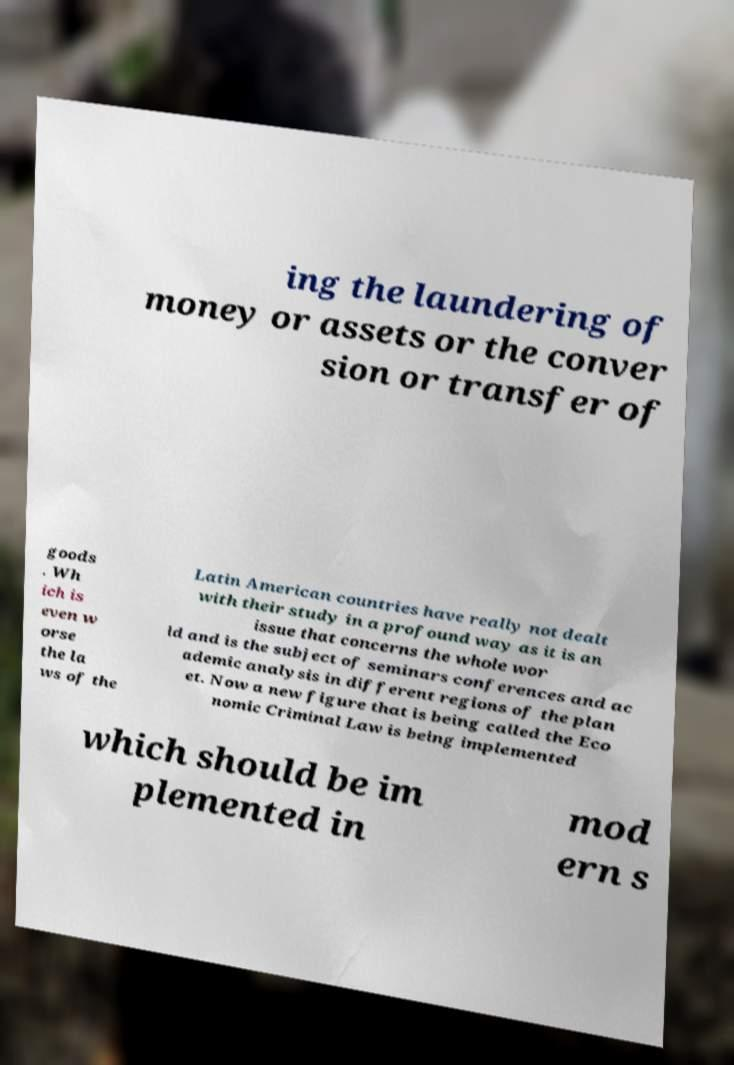Can you accurately transcribe the text from the provided image for me? ing the laundering of money or assets or the conver sion or transfer of goods . Wh ich is even w orse the la ws of the Latin American countries have really not dealt with their study in a profound way as it is an issue that concerns the whole wor ld and is the subject of seminars conferences and ac ademic analysis in different regions of the plan et. Now a new figure that is being called the Eco nomic Criminal Law is being implemented which should be im plemented in mod ern s 